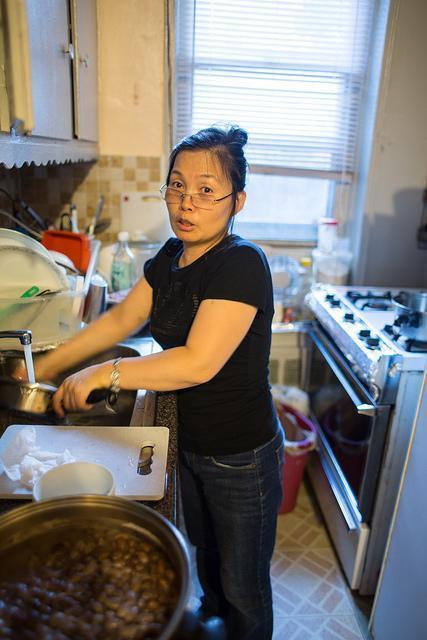What chore does the woman perform?
Select the accurate answer and provide justification: `Answer: choice
Rationale: srationale.`
Options: Dusting, basting, dish washing, frying. Answer: dish washing.
Rationale: She has water running and she is cleaning the dishes off. 